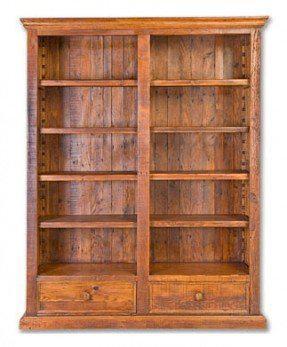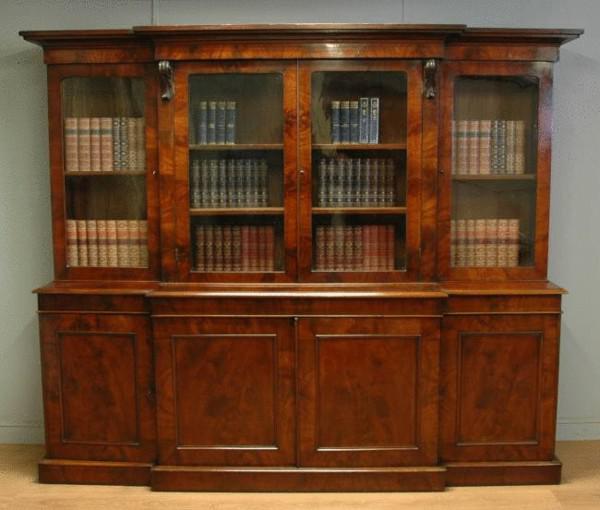The first image is the image on the left, the second image is the image on the right. For the images shown, is this caption "In one of the images there is a bookshelf with books on it." true? Answer yes or no. Yes. 